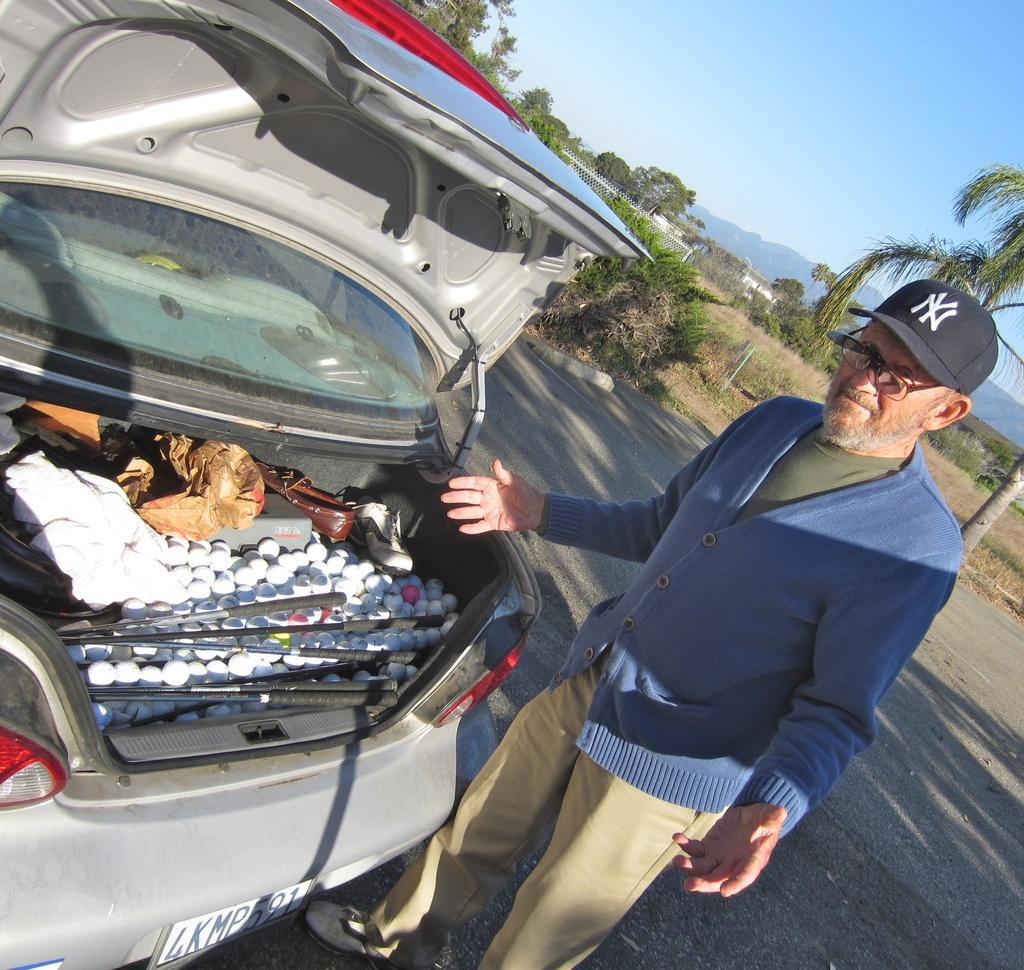Please provide a concise description of this image. In this picture I can observe a man standing on the road, wearing blue color sweater and black color cap on his head. In front of him there is a car. In the background there are tree and sky. 